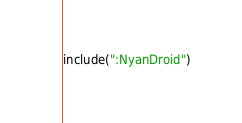<code> <loc_0><loc_0><loc_500><loc_500><_Kotlin_>include(":NyanDroid")
</code> 